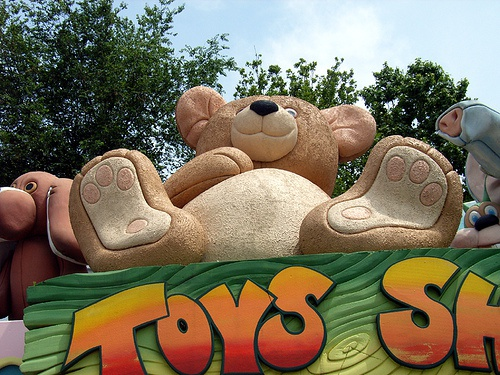Describe the objects in this image and their specific colors. I can see a teddy bear in gray, tan, and maroon tones in this image. 